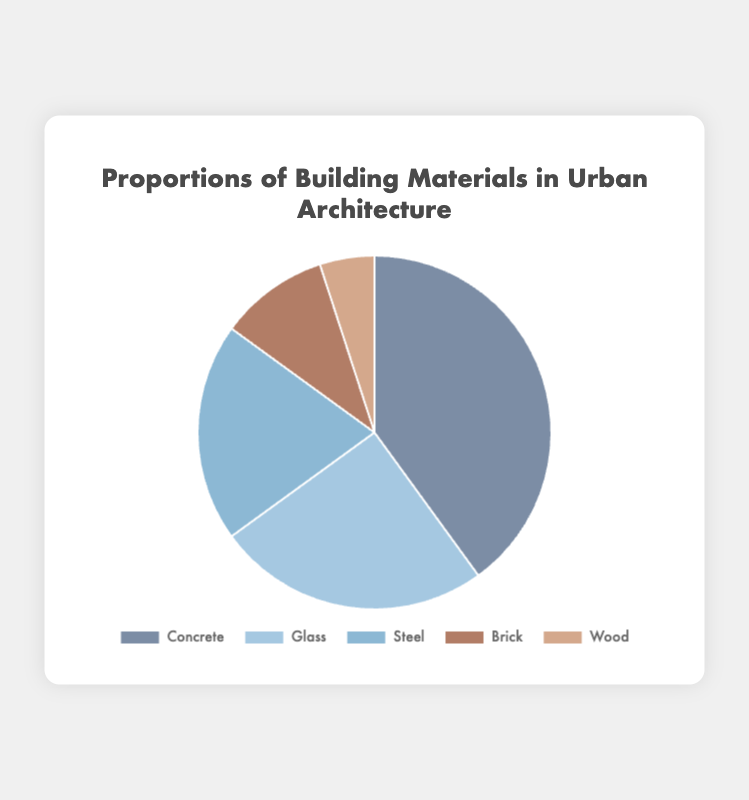What material holds the largest proportion? The pie chart shows sections corresponding to different materials. The largest section in terms of area represents Concrete.
Answer: Concrete Which material has a larger proportion, Glass or Steel? By comparing the sections representing Glass and Steel, the section for Glass is visually larger than that for Steel.
Answer: Glass What is the combined proportion of Brick and Wood? The proportion of Brick is 10% and that of Wood is 5%. Summing these gives 10% + 5% = 15%.
Answer: 15% Compare the combined proportion of Concrete and Glass to Steel and Brick. Which combination has the greater proportion? Concrete and Glass together sum to 40% + 25% = 65%, while Steel and Brick together sum to 20% + 10% = 30%. Therefore, Concrete and Glass have a greater combined proportion.
Answer: Concrete and Glass What is the difference in proportion between the material with the highest representation and the one with the lowest? Concrete is the highest at 40% and Wood is the lowest at 5%. The difference is 40% - 5% = 35%.
Answer: 35% Which two materials together make up the majority of the usage? Concrete (40%) and Glass (25%) together sum to 65%, which is more than 50%. No other combination surpasses 50%.
Answer: Concrete and Glass Which materials have proportions below 20%? The materials represented with proportions below 20% are Brick (10%) and Wood (5%).
Answer: Brick and Wood If the proportions of Steel and Wood were swapped, which would then have the smallest proportion? If Steel and Wood were swapped, Wood would then have 20% and Steel would have 5%. This would make Steel the smallest proportion.
Answer: Steel Which material is represented by the second largest segment? By looking at the pie chart, the second largest segment corresponds to Glass.
Answer: Glass Arrange the materials in descending order of their proportions. The segments can be ranked from largest to smallest: Concrete (40%), Glass (25%), Steel (20%), Brick (10%), Wood (5%).
Answer: Concrete, Glass, Steel, Brick, Wood 